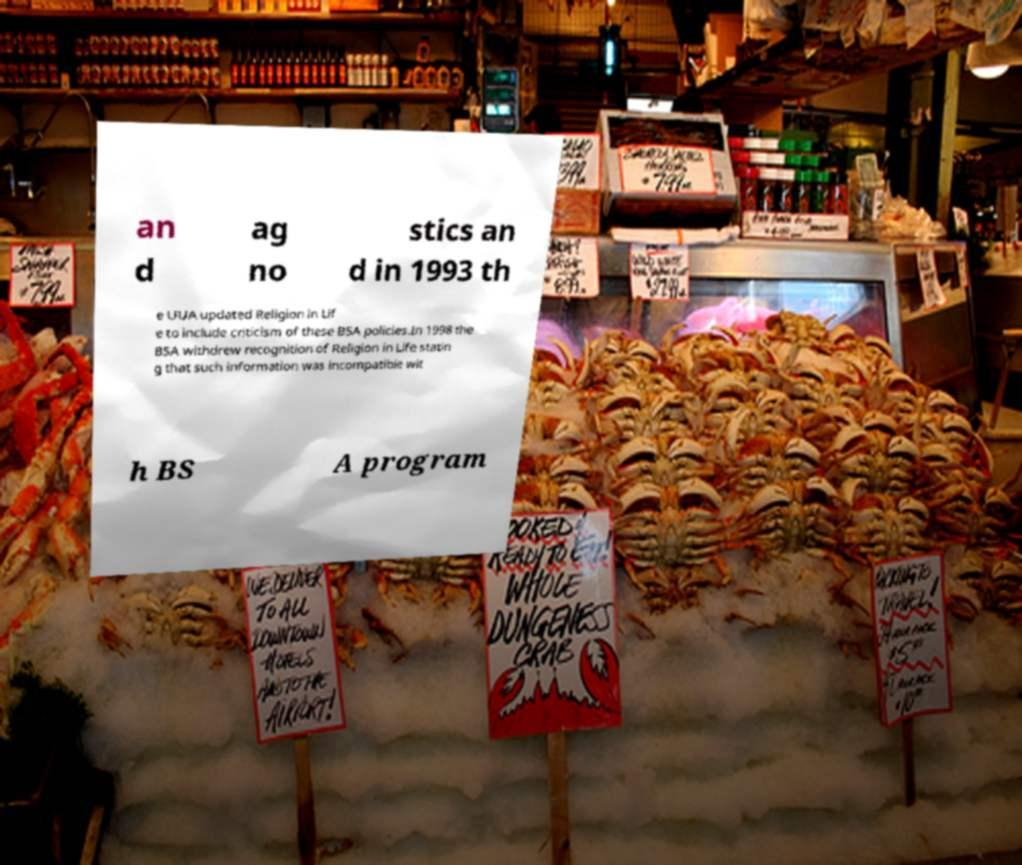There's text embedded in this image that I need extracted. Can you transcribe it verbatim? an d ag no stics an d in 1993 th e UUA updated Religion in Lif e to include criticism of these BSA policies.In 1998 the BSA withdrew recognition of Religion in Life statin g that such information was incompatible wit h BS A program 